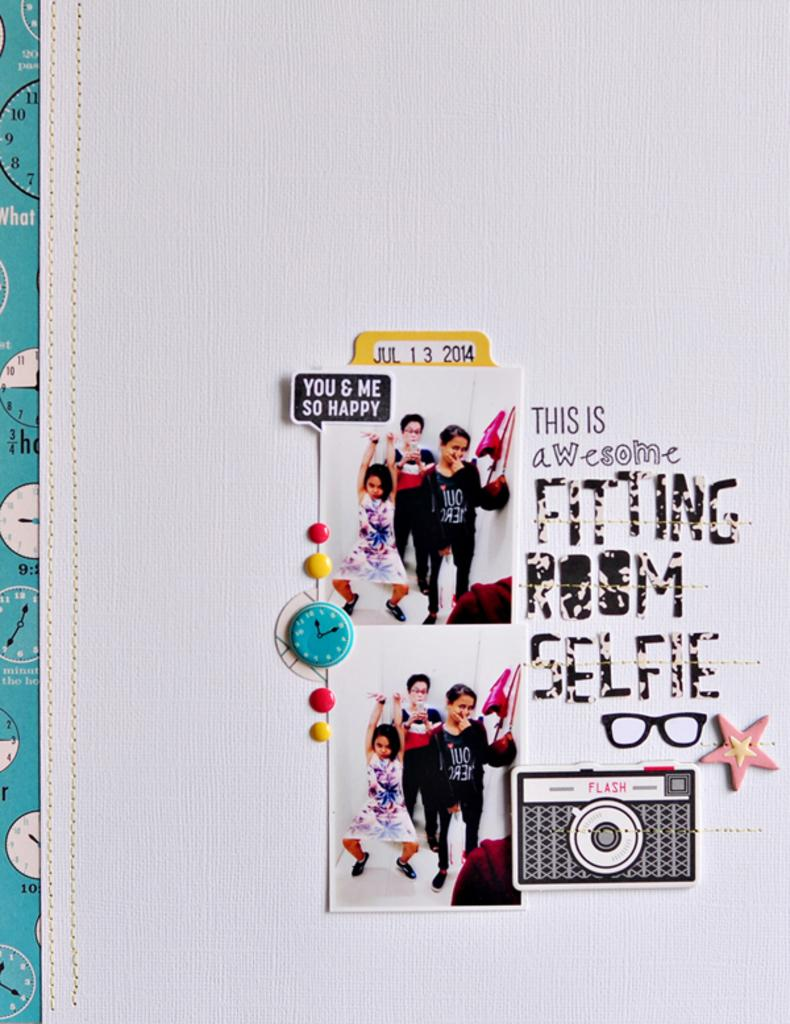<image>
Share a concise interpretation of the image provided. the words fitting room that are on a wall 